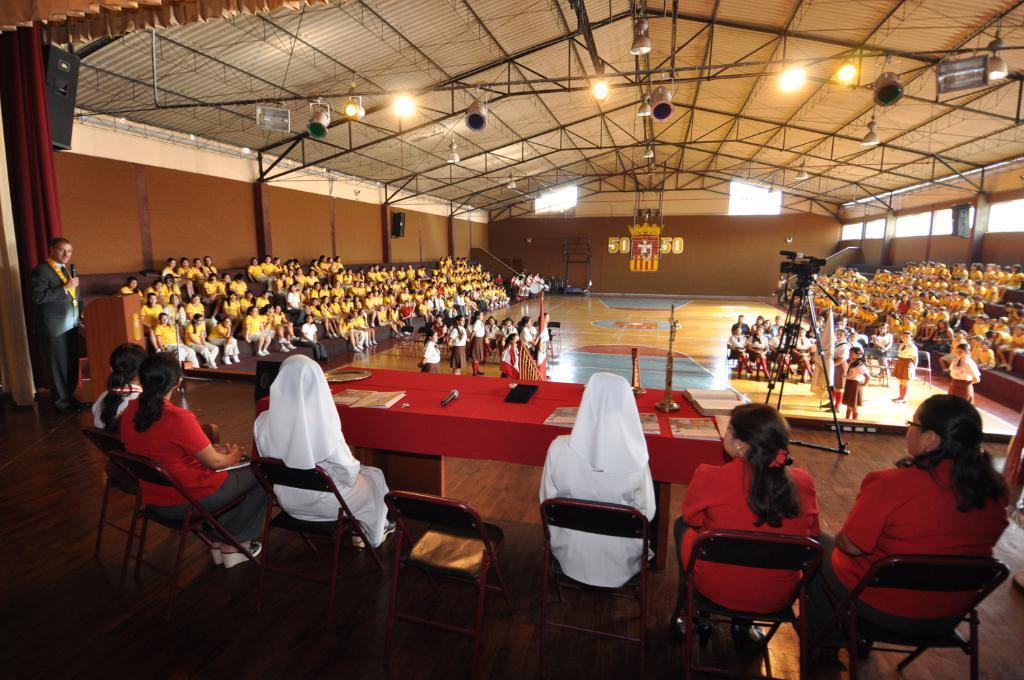Can you describe this image briefly? Here we can see a group of people sitting on a chair on the floor, and in front there is the table and some objects on it, and here a person is standing and holding a microphone in his hand , and here the group of people are standing, and here are the lights, and here are the yellow dress persons are sitting. 